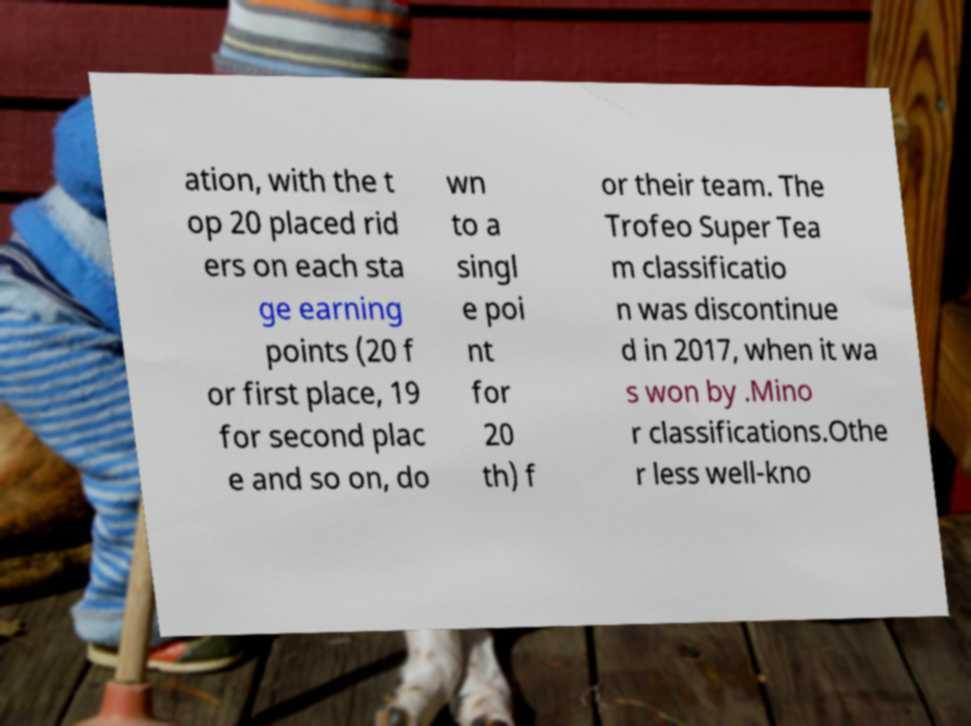I need the written content from this picture converted into text. Can you do that? ation, with the t op 20 placed rid ers on each sta ge earning points (20 f or first place, 19 for second plac e and so on, do wn to a singl e poi nt for 20 th) f or their team. The Trofeo Super Tea m classificatio n was discontinue d in 2017, when it wa s won by .Mino r classifications.Othe r less well-kno 